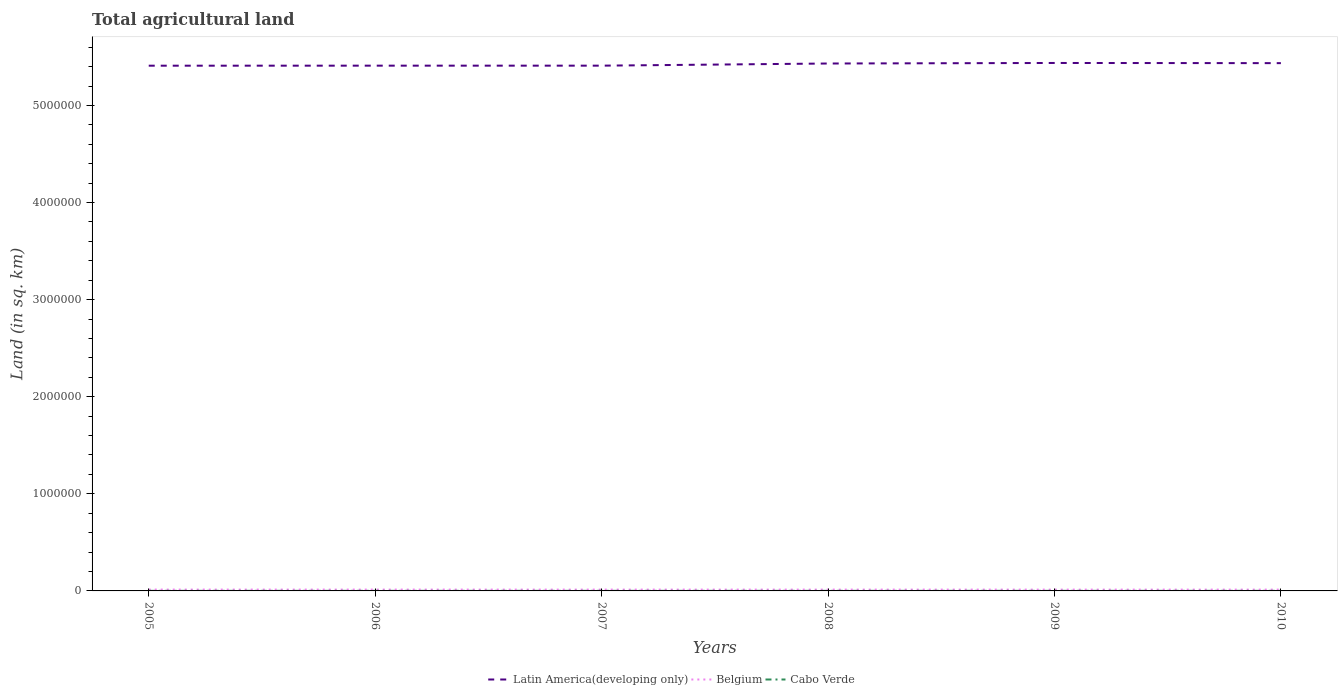Across all years, what is the maximum total agricultural land in Latin America(developing only)?
Your response must be concise. 5.41e+06. In which year was the total agricultural land in Belgium maximum?
Your answer should be compact. 2010. What is the total total agricultural land in Latin America(developing only) in the graph?
Give a very brief answer. -5547.7. What is the difference between the highest and the second highest total agricultural land in Belgium?
Offer a very short reply. 280. What is the difference between the highest and the lowest total agricultural land in Cabo Verde?
Your answer should be compact. 3. What is the difference between two consecutive major ticks on the Y-axis?
Provide a short and direct response. 1.00e+06. Does the graph contain grids?
Your response must be concise. No. How many legend labels are there?
Your response must be concise. 3. How are the legend labels stacked?
Offer a very short reply. Horizontal. What is the title of the graph?
Your response must be concise. Total agricultural land. Does "Cote d'Ivoire" appear as one of the legend labels in the graph?
Give a very brief answer. No. What is the label or title of the Y-axis?
Make the answer very short. Land (in sq. km). What is the Land (in sq. km) of Latin America(developing only) in 2005?
Ensure brevity in your answer.  5.41e+06. What is the Land (in sq. km) of Belgium in 2005?
Offer a very short reply. 1.38e+04. What is the Land (in sq. km) in Cabo Verde in 2005?
Provide a short and direct response. 750. What is the Land (in sq. km) of Latin America(developing only) in 2006?
Make the answer very short. 5.41e+06. What is the Land (in sq. km) of Belgium in 2006?
Your answer should be compact. 1.38e+04. What is the Land (in sq. km) of Cabo Verde in 2006?
Offer a very short reply. 760. What is the Land (in sq. km) in Latin America(developing only) in 2007?
Your answer should be compact. 5.41e+06. What is the Land (in sq. km) in Belgium in 2007?
Make the answer very short. 1.37e+04. What is the Land (in sq. km) of Cabo Verde in 2007?
Your answer should be very brief. 760. What is the Land (in sq. km) in Latin America(developing only) in 2008?
Your answer should be very brief. 5.43e+06. What is the Land (in sq. km) of Belgium in 2008?
Provide a short and direct response. 1.37e+04. What is the Land (in sq. km) in Cabo Verde in 2008?
Provide a short and direct response. 780. What is the Land (in sq. km) in Latin America(developing only) in 2009?
Your answer should be very brief. 5.44e+06. What is the Land (in sq. km) of Belgium in 2009?
Your response must be concise. 1.36e+04. What is the Land (in sq. km) in Cabo Verde in 2009?
Provide a short and direct response. 780. What is the Land (in sq. km) of Latin America(developing only) in 2010?
Your response must be concise. 5.44e+06. What is the Land (in sq. km) in Belgium in 2010?
Give a very brief answer. 1.36e+04. What is the Land (in sq. km) in Cabo Verde in 2010?
Ensure brevity in your answer.  780. Across all years, what is the maximum Land (in sq. km) of Latin America(developing only)?
Your answer should be compact. 5.44e+06. Across all years, what is the maximum Land (in sq. km) of Belgium?
Your answer should be compact. 1.38e+04. Across all years, what is the maximum Land (in sq. km) of Cabo Verde?
Offer a very short reply. 780. Across all years, what is the minimum Land (in sq. km) in Latin America(developing only)?
Your response must be concise. 5.41e+06. Across all years, what is the minimum Land (in sq. km) of Belgium?
Give a very brief answer. 1.36e+04. Across all years, what is the minimum Land (in sq. km) in Cabo Verde?
Your answer should be very brief. 750. What is the total Land (in sq. km) of Latin America(developing only) in the graph?
Ensure brevity in your answer.  3.25e+07. What is the total Land (in sq. km) in Belgium in the graph?
Provide a short and direct response. 8.22e+04. What is the total Land (in sq. km) of Cabo Verde in the graph?
Provide a succinct answer. 4610. What is the difference between the Land (in sq. km) of Latin America(developing only) in 2005 and that in 2006?
Your answer should be compact. -370. What is the difference between the Land (in sq. km) of Belgium in 2005 and that in 2006?
Offer a terse response. 30. What is the difference between the Land (in sq. km) of Cabo Verde in 2005 and that in 2006?
Your answer should be compact. -10. What is the difference between the Land (in sq. km) of Latin America(developing only) in 2005 and that in 2007?
Make the answer very short. -394. What is the difference between the Land (in sq. km) in Belgium in 2005 and that in 2007?
Your response must be concise. 160. What is the difference between the Land (in sq. km) in Cabo Verde in 2005 and that in 2007?
Offer a terse response. -10. What is the difference between the Land (in sq. km) in Latin America(developing only) in 2005 and that in 2008?
Your answer should be very brief. -2.25e+04. What is the difference between the Land (in sq. km) of Belgium in 2005 and that in 2008?
Provide a succinct answer. 170. What is the difference between the Land (in sq. km) of Latin America(developing only) in 2005 and that in 2009?
Keep it short and to the point. -2.81e+04. What is the difference between the Land (in sq. km) of Belgium in 2005 and that in 2009?
Ensure brevity in your answer.  270. What is the difference between the Land (in sq. km) in Latin America(developing only) in 2005 and that in 2010?
Ensure brevity in your answer.  -2.63e+04. What is the difference between the Land (in sq. km) of Belgium in 2005 and that in 2010?
Give a very brief answer. 280. What is the difference between the Land (in sq. km) in Cabo Verde in 2005 and that in 2010?
Give a very brief answer. -30. What is the difference between the Land (in sq. km) of Latin America(developing only) in 2006 and that in 2007?
Keep it short and to the point. -24. What is the difference between the Land (in sq. km) of Belgium in 2006 and that in 2007?
Give a very brief answer. 130. What is the difference between the Land (in sq. km) of Latin America(developing only) in 2006 and that in 2008?
Offer a terse response. -2.22e+04. What is the difference between the Land (in sq. km) in Belgium in 2006 and that in 2008?
Give a very brief answer. 140. What is the difference between the Land (in sq. km) of Cabo Verde in 2006 and that in 2008?
Ensure brevity in your answer.  -20. What is the difference between the Land (in sq. km) of Latin America(developing only) in 2006 and that in 2009?
Your response must be concise. -2.77e+04. What is the difference between the Land (in sq. km) in Belgium in 2006 and that in 2009?
Offer a terse response. 240. What is the difference between the Land (in sq. km) in Latin America(developing only) in 2006 and that in 2010?
Your response must be concise. -2.59e+04. What is the difference between the Land (in sq. km) of Belgium in 2006 and that in 2010?
Your answer should be compact. 250. What is the difference between the Land (in sq. km) in Cabo Verde in 2006 and that in 2010?
Provide a succinct answer. -20. What is the difference between the Land (in sq. km) of Latin America(developing only) in 2007 and that in 2008?
Provide a succinct answer. -2.21e+04. What is the difference between the Land (in sq. km) of Latin America(developing only) in 2007 and that in 2009?
Provide a succinct answer. -2.77e+04. What is the difference between the Land (in sq. km) in Belgium in 2007 and that in 2009?
Offer a very short reply. 110. What is the difference between the Land (in sq. km) of Cabo Verde in 2007 and that in 2009?
Give a very brief answer. -20. What is the difference between the Land (in sq. km) in Latin America(developing only) in 2007 and that in 2010?
Give a very brief answer. -2.59e+04. What is the difference between the Land (in sq. km) in Belgium in 2007 and that in 2010?
Keep it short and to the point. 120. What is the difference between the Land (in sq. km) of Latin America(developing only) in 2008 and that in 2009?
Provide a succinct answer. -5547.7. What is the difference between the Land (in sq. km) of Belgium in 2008 and that in 2009?
Ensure brevity in your answer.  100. What is the difference between the Land (in sq. km) of Cabo Verde in 2008 and that in 2009?
Provide a succinct answer. 0. What is the difference between the Land (in sq. km) in Latin America(developing only) in 2008 and that in 2010?
Provide a short and direct response. -3748.7. What is the difference between the Land (in sq. km) of Belgium in 2008 and that in 2010?
Make the answer very short. 110. What is the difference between the Land (in sq. km) of Cabo Verde in 2008 and that in 2010?
Provide a succinct answer. 0. What is the difference between the Land (in sq. km) of Latin America(developing only) in 2009 and that in 2010?
Offer a very short reply. 1799. What is the difference between the Land (in sq. km) of Belgium in 2009 and that in 2010?
Make the answer very short. 10. What is the difference between the Land (in sq. km) in Latin America(developing only) in 2005 and the Land (in sq. km) in Belgium in 2006?
Keep it short and to the point. 5.40e+06. What is the difference between the Land (in sq. km) of Latin America(developing only) in 2005 and the Land (in sq. km) of Cabo Verde in 2006?
Your answer should be very brief. 5.41e+06. What is the difference between the Land (in sq. km) of Belgium in 2005 and the Land (in sq. km) of Cabo Verde in 2006?
Make the answer very short. 1.31e+04. What is the difference between the Land (in sq. km) in Latin America(developing only) in 2005 and the Land (in sq. km) in Belgium in 2007?
Your answer should be very brief. 5.40e+06. What is the difference between the Land (in sq. km) in Latin America(developing only) in 2005 and the Land (in sq. km) in Cabo Verde in 2007?
Provide a succinct answer. 5.41e+06. What is the difference between the Land (in sq. km) in Belgium in 2005 and the Land (in sq. km) in Cabo Verde in 2007?
Give a very brief answer. 1.31e+04. What is the difference between the Land (in sq. km) in Latin America(developing only) in 2005 and the Land (in sq. km) in Belgium in 2008?
Your answer should be very brief. 5.40e+06. What is the difference between the Land (in sq. km) of Latin America(developing only) in 2005 and the Land (in sq. km) of Cabo Verde in 2008?
Keep it short and to the point. 5.41e+06. What is the difference between the Land (in sq. km) of Belgium in 2005 and the Land (in sq. km) of Cabo Verde in 2008?
Ensure brevity in your answer.  1.31e+04. What is the difference between the Land (in sq. km) of Latin America(developing only) in 2005 and the Land (in sq. km) of Belgium in 2009?
Offer a terse response. 5.40e+06. What is the difference between the Land (in sq. km) of Latin America(developing only) in 2005 and the Land (in sq. km) of Cabo Verde in 2009?
Ensure brevity in your answer.  5.41e+06. What is the difference between the Land (in sq. km) of Belgium in 2005 and the Land (in sq. km) of Cabo Verde in 2009?
Give a very brief answer. 1.31e+04. What is the difference between the Land (in sq. km) in Latin America(developing only) in 2005 and the Land (in sq. km) in Belgium in 2010?
Keep it short and to the point. 5.40e+06. What is the difference between the Land (in sq. km) in Latin America(developing only) in 2005 and the Land (in sq. km) in Cabo Verde in 2010?
Offer a very short reply. 5.41e+06. What is the difference between the Land (in sq. km) in Belgium in 2005 and the Land (in sq. km) in Cabo Verde in 2010?
Provide a succinct answer. 1.31e+04. What is the difference between the Land (in sq. km) in Latin America(developing only) in 2006 and the Land (in sq. km) in Belgium in 2007?
Your answer should be very brief. 5.40e+06. What is the difference between the Land (in sq. km) in Latin America(developing only) in 2006 and the Land (in sq. km) in Cabo Verde in 2007?
Offer a terse response. 5.41e+06. What is the difference between the Land (in sq. km) of Belgium in 2006 and the Land (in sq. km) of Cabo Verde in 2007?
Your answer should be compact. 1.31e+04. What is the difference between the Land (in sq. km) of Latin America(developing only) in 2006 and the Land (in sq. km) of Belgium in 2008?
Offer a terse response. 5.40e+06. What is the difference between the Land (in sq. km) of Latin America(developing only) in 2006 and the Land (in sq. km) of Cabo Verde in 2008?
Offer a terse response. 5.41e+06. What is the difference between the Land (in sq. km) of Belgium in 2006 and the Land (in sq. km) of Cabo Verde in 2008?
Offer a terse response. 1.30e+04. What is the difference between the Land (in sq. km) in Latin America(developing only) in 2006 and the Land (in sq. km) in Belgium in 2009?
Keep it short and to the point. 5.40e+06. What is the difference between the Land (in sq. km) of Latin America(developing only) in 2006 and the Land (in sq. km) of Cabo Verde in 2009?
Your answer should be compact. 5.41e+06. What is the difference between the Land (in sq. km) in Belgium in 2006 and the Land (in sq. km) in Cabo Verde in 2009?
Keep it short and to the point. 1.30e+04. What is the difference between the Land (in sq. km) of Latin America(developing only) in 2006 and the Land (in sq. km) of Belgium in 2010?
Give a very brief answer. 5.40e+06. What is the difference between the Land (in sq. km) in Latin America(developing only) in 2006 and the Land (in sq. km) in Cabo Verde in 2010?
Offer a very short reply. 5.41e+06. What is the difference between the Land (in sq. km) of Belgium in 2006 and the Land (in sq. km) of Cabo Verde in 2010?
Ensure brevity in your answer.  1.30e+04. What is the difference between the Land (in sq. km) of Latin America(developing only) in 2007 and the Land (in sq. km) of Belgium in 2008?
Keep it short and to the point. 5.40e+06. What is the difference between the Land (in sq. km) in Latin America(developing only) in 2007 and the Land (in sq. km) in Cabo Verde in 2008?
Provide a succinct answer. 5.41e+06. What is the difference between the Land (in sq. km) in Belgium in 2007 and the Land (in sq. km) in Cabo Verde in 2008?
Provide a succinct answer. 1.29e+04. What is the difference between the Land (in sq. km) of Latin America(developing only) in 2007 and the Land (in sq. km) of Belgium in 2009?
Offer a very short reply. 5.40e+06. What is the difference between the Land (in sq. km) of Latin America(developing only) in 2007 and the Land (in sq. km) of Cabo Verde in 2009?
Offer a terse response. 5.41e+06. What is the difference between the Land (in sq. km) of Belgium in 2007 and the Land (in sq. km) of Cabo Verde in 2009?
Your response must be concise. 1.29e+04. What is the difference between the Land (in sq. km) of Latin America(developing only) in 2007 and the Land (in sq. km) of Belgium in 2010?
Your answer should be very brief. 5.40e+06. What is the difference between the Land (in sq. km) of Latin America(developing only) in 2007 and the Land (in sq. km) of Cabo Verde in 2010?
Your answer should be compact. 5.41e+06. What is the difference between the Land (in sq. km) of Belgium in 2007 and the Land (in sq. km) of Cabo Verde in 2010?
Your answer should be compact. 1.29e+04. What is the difference between the Land (in sq. km) of Latin America(developing only) in 2008 and the Land (in sq. km) of Belgium in 2009?
Give a very brief answer. 5.42e+06. What is the difference between the Land (in sq. km) in Latin America(developing only) in 2008 and the Land (in sq. km) in Cabo Verde in 2009?
Your answer should be very brief. 5.43e+06. What is the difference between the Land (in sq. km) of Belgium in 2008 and the Land (in sq. km) of Cabo Verde in 2009?
Offer a terse response. 1.29e+04. What is the difference between the Land (in sq. km) of Latin America(developing only) in 2008 and the Land (in sq. km) of Belgium in 2010?
Provide a succinct answer. 5.42e+06. What is the difference between the Land (in sq. km) of Latin America(developing only) in 2008 and the Land (in sq. km) of Cabo Verde in 2010?
Your answer should be very brief. 5.43e+06. What is the difference between the Land (in sq. km) in Belgium in 2008 and the Land (in sq. km) in Cabo Verde in 2010?
Your answer should be very brief. 1.29e+04. What is the difference between the Land (in sq. km) in Latin America(developing only) in 2009 and the Land (in sq. km) in Belgium in 2010?
Make the answer very short. 5.42e+06. What is the difference between the Land (in sq. km) in Latin America(developing only) in 2009 and the Land (in sq. km) in Cabo Verde in 2010?
Your answer should be compact. 5.44e+06. What is the difference between the Land (in sq. km) in Belgium in 2009 and the Land (in sq. km) in Cabo Verde in 2010?
Your answer should be compact. 1.28e+04. What is the average Land (in sq. km) of Latin America(developing only) per year?
Your answer should be very brief. 5.42e+06. What is the average Land (in sq. km) of Belgium per year?
Offer a very short reply. 1.37e+04. What is the average Land (in sq. km) of Cabo Verde per year?
Keep it short and to the point. 768.33. In the year 2005, what is the difference between the Land (in sq. km) in Latin America(developing only) and Land (in sq. km) in Belgium?
Provide a succinct answer. 5.40e+06. In the year 2005, what is the difference between the Land (in sq. km) in Latin America(developing only) and Land (in sq. km) in Cabo Verde?
Ensure brevity in your answer.  5.41e+06. In the year 2005, what is the difference between the Land (in sq. km) in Belgium and Land (in sq. km) in Cabo Verde?
Offer a very short reply. 1.31e+04. In the year 2006, what is the difference between the Land (in sq. km) of Latin America(developing only) and Land (in sq. km) of Belgium?
Offer a terse response. 5.40e+06. In the year 2006, what is the difference between the Land (in sq. km) in Latin America(developing only) and Land (in sq. km) in Cabo Verde?
Your answer should be very brief. 5.41e+06. In the year 2006, what is the difference between the Land (in sq. km) in Belgium and Land (in sq. km) in Cabo Verde?
Give a very brief answer. 1.31e+04. In the year 2007, what is the difference between the Land (in sq. km) in Latin America(developing only) and Land (in sq. km) in Belgium?
Offer a very short reply. 5.40e+06. In the year 2007, what is the difference between the Land (in sq. km) of Latin America(developing only) and Land (in sq. km) of Cabo Verde?
Your answer should be compact. 5.41e+06. In the year 2007, what is the difference between the Land (in sq. km) in Belgium and Land (in sq. km) in Cabo Verde?
Offer a terse response. 1.29e+04. In the year 2008, what is the difference between the Land (in sq. km) of Latin America(developing only) and Land (in sq. km) of Belgium?
Make the answer very short. 5.42e+06. In the year 2008, what is the difference between the Land (in sq. km) in Latin America(developing only) and Land (in sq. km) in Cabo Verde?
Offer a very short reply. 5.43e+06. In the year 2008, what is the difference between the Land (in sq. km) of Belgium and Land (in sq. km) of Cabo Verde?
Provide a short and direct response. 1.29e+04. In the year 2009, what is the difference between the Land (in sq. km) in Latin America(developing only) and Land (in sq. km) in Belgium?
Make the answer very short. 5.42e+06. In the year 2009, what is the difference between the Land (in sq. km) in Latin America(developing only) and Land (in sq. km) in Cabo Verde?
Ensure brevity in your answer.  5.44e+06. In the year 2009, what is the difference between the Land (in sq. km) of Belgium and Land (in sq. km) of Cabo Verde?
Give a very brief answer. 1.28e+04. In the year 2010, what is the difference between the Land (in sq. km) of Latin America(developing only) and Land (in sq. km) of Belgium?
Make the answer very short. 5.42e+06. In the year 2010, what is the difference between the Land (in sq. km) of Latin America(developing only) and Land (in sq. km) of Cabo Verde?
Your answer should be very brief. 5.44e+06. In the year 2010, what is the difference between the Land (in sq. km) of Belgium and Land (in sq. km) of Cabo Verde?
Give a very brief answer. 1.28e+04. What is the ratio of the Land (in sq. km) in Belgium in 2005 to that in 2006?
Ensure brevity in your answer.  1. What is the ratio of the Land (in sq. km) of Latin America(developing only) in 2005 to that in 2007?
Offer a very short reply. 1. What is the ratio of the Land (in sq. km) of Belgium in 2005 to that in 2007?
Ensure brevity in your answer.  1.01. What is the ratio of the Land (in sq. km) of Belgium in 2005 to that in 2008?
Provide a succinct answer. 1.01. What is the ratio of the Land (in sq. km) of Cabo Verde in 2005 to that in 2008?
Your answer should be very brief. 0.96. What is the ratio of the Land (in sq. km) of Belgium in 2005 to that in 2009?
Offer a very short reply. 1.02. What is the ratio of the Land (in sq. km) in Cabo Verde in 2005 to that in 2009?
Provide a short and direct response. 0.96. What is the ratio of the Land (in sq. km) of Latin America(developing only) in 2005 to that in 2010?
Offer a terse response. 1. What is the ratio of the Land (in sq. km) in Belgium in 2005 to that in 2010?
Give a very brief answer. 1.02. What is the ratio of the Land (in sq. km) in Cabo Verde in 2005 to that in 2010?
Make the answer very short. 0.96. What is the ratio of the Land (in sq. km) in Belgium in 2006 to that in 2007?
Give a very brief answer. 1.01. What is the ratio of the Land (in sq. km) of Latin America(developing only) in 2006 to that in 2008?
Your response must be concise. 1. What is the ratio of the Land (in sq. km) in Belgium in 2006 to that in 2008?
Provide a succinct answer. 1.01. What is the ratio of the Land (in sq. km) of Cabo Verde in 2006 to that in 2008?
Offer a terse response. 0.97. What is the ratio of the Land (in sq. km) in Latin America(developing only) in 2006 to that in 2009?
Your answer should be very brief. 0.99. What is the ratio of the Land (in sq. km) of Belgium in 2006 to that in 2009?
Make the answer very short. 1.02. What is the ratio of the Land (in sq. km) in Cabo Verde in 2006 to that in 2009?
Offer a terse response. 0.97. What is the ratio of the Land (in sq. km) of Latin America(developing only) in 2006 to that in 2010?
Offer a very short reply. 1. What is the ratio of the Land (in sq. km) of Belgium in 2006 to that in 2010?
Provide a short and direct response. 1.02. What is the ratio of the Land (in sq. km) of Cabo Verde in 2006 to that in 2010?
Provide a short and direct response. 0.97. What is the ratio of the Land (in sq. km) in Cabo Verde in 2007 to that in 2008?
Provide a short and direct response. 0.97. What is the ratio of the Land (in sq. km) in Cabo Verde in 2007 to that in 2009?
Provide a succinct answer. 0.97. What is the ratio of the Land (in sq. km) in Latin America(developing only) in 2007 to that in 2010?
Provide a short and direct response. 1. What is the ratio of the Land (in sq. km) of Belgium in 2007 to that in 2010?
Keep it short and to the point. 1.01. What is the ratio of the Land (in sq. km) in Cabo Verde in 2007 to that in 2010?
Offer a terse response. 0.97. What is the ratio of the Land (in sq. km) in Belgium in 2008 to that in 2009?
Your answer should be compact. 1.01. What is the ratio of the Land (in sq. km) in Latin America(developing only) in 2009 to that in 2010?
Provide a short and direct response. 1. What is the ratio of the Land (in sq. km) in Cabo Verde in 2009 to that in 2010?
Your response must be concise. 1. What is the difference between the highest and the second highest Land (in sq. km) of Latin America(developing only)?
Offer a very short reply. 1799. What is the difference between the highest and the second highest Land (in sq. km) in Belgium?
Ensure brevity in your answer.  30. What is the difference between the highest and the second highest Land (in sq. km) of Cabo Verde?
Keep it short and to the point. 0. What is the difference between the highest and the lowest Land (in sq. km) in Latin America(developing only)?
Offer a very short reply. 2.81e+04. What is the difference between the highest and the lowest Land (in sq. km) in Belgium?
Offer a very short reply. 280. 